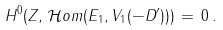Convert formula to latex. <formula><loc_0><loc_0><loc_500><loc_500>H ^ { 0 } ( Z , \, \mathcal { H } o m ( E _ { 1 } , V _ { 1 } ( - D ^ { \prime } ) ) ) \, = \, 0 \, .</formula> 